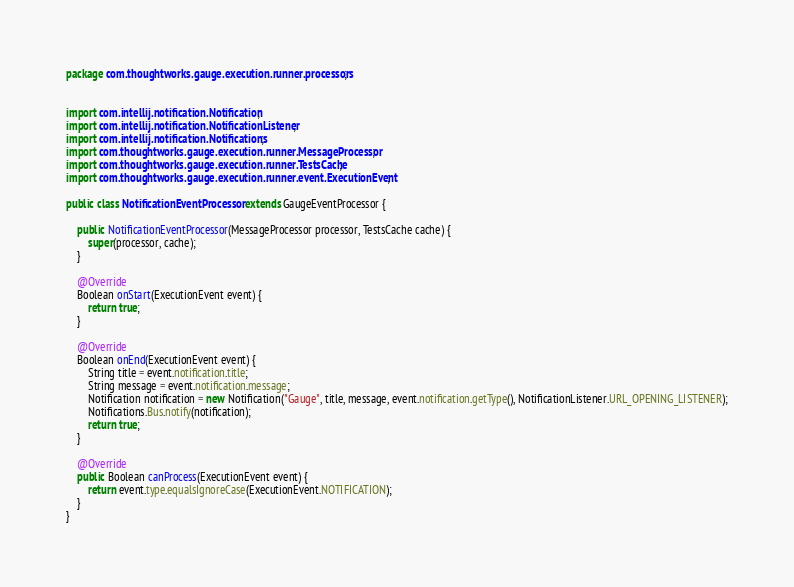<code> <loc_0><loc_0><loc_500><loc_500><_Java_>package com.thoughtworks.gauge.execution.runner.processors;


import com.intellij.notification.Notification;
import com.intellij.notification.NotificationListener;
import com.intellij.notification.Notifications;
import com.thoughtworks.gauge.execution.runner.MessageProcessor;
import com.thoughtworks.gauge.execution.runner.TestsCache;
import com.thoughtworks.gauge.execution.runner.event.ExecutionEvent;

public class NotificationEventProcessor extends GaugeEventProcessor {

    public NotificationEventProcessor(MessageProcessor processor, TestsCache cache) {
        super(processor, cache);
    }

    @Override
    Boolean onStart(ExecutionEvent event) {
        return true;
    }

    @Override
    Boolean onEnd(ExecutionEvent event) {
        String title = event.notification.title;
        String message = event.notification.message;
        Notification notification = new Notification("Gauge", title, message, event.notification.getType(), NotificationListener.URL_OPENING_LISTENER);
        Notifications.Bus.notify(notification);
        return true;
    }

    @Override
    public Boolean canProcess(ExecutionEvent event) {
        return event.type.equalsIgnoreCase(ExecutionEvent.NOTIFICATION);
    }
}
</code> 